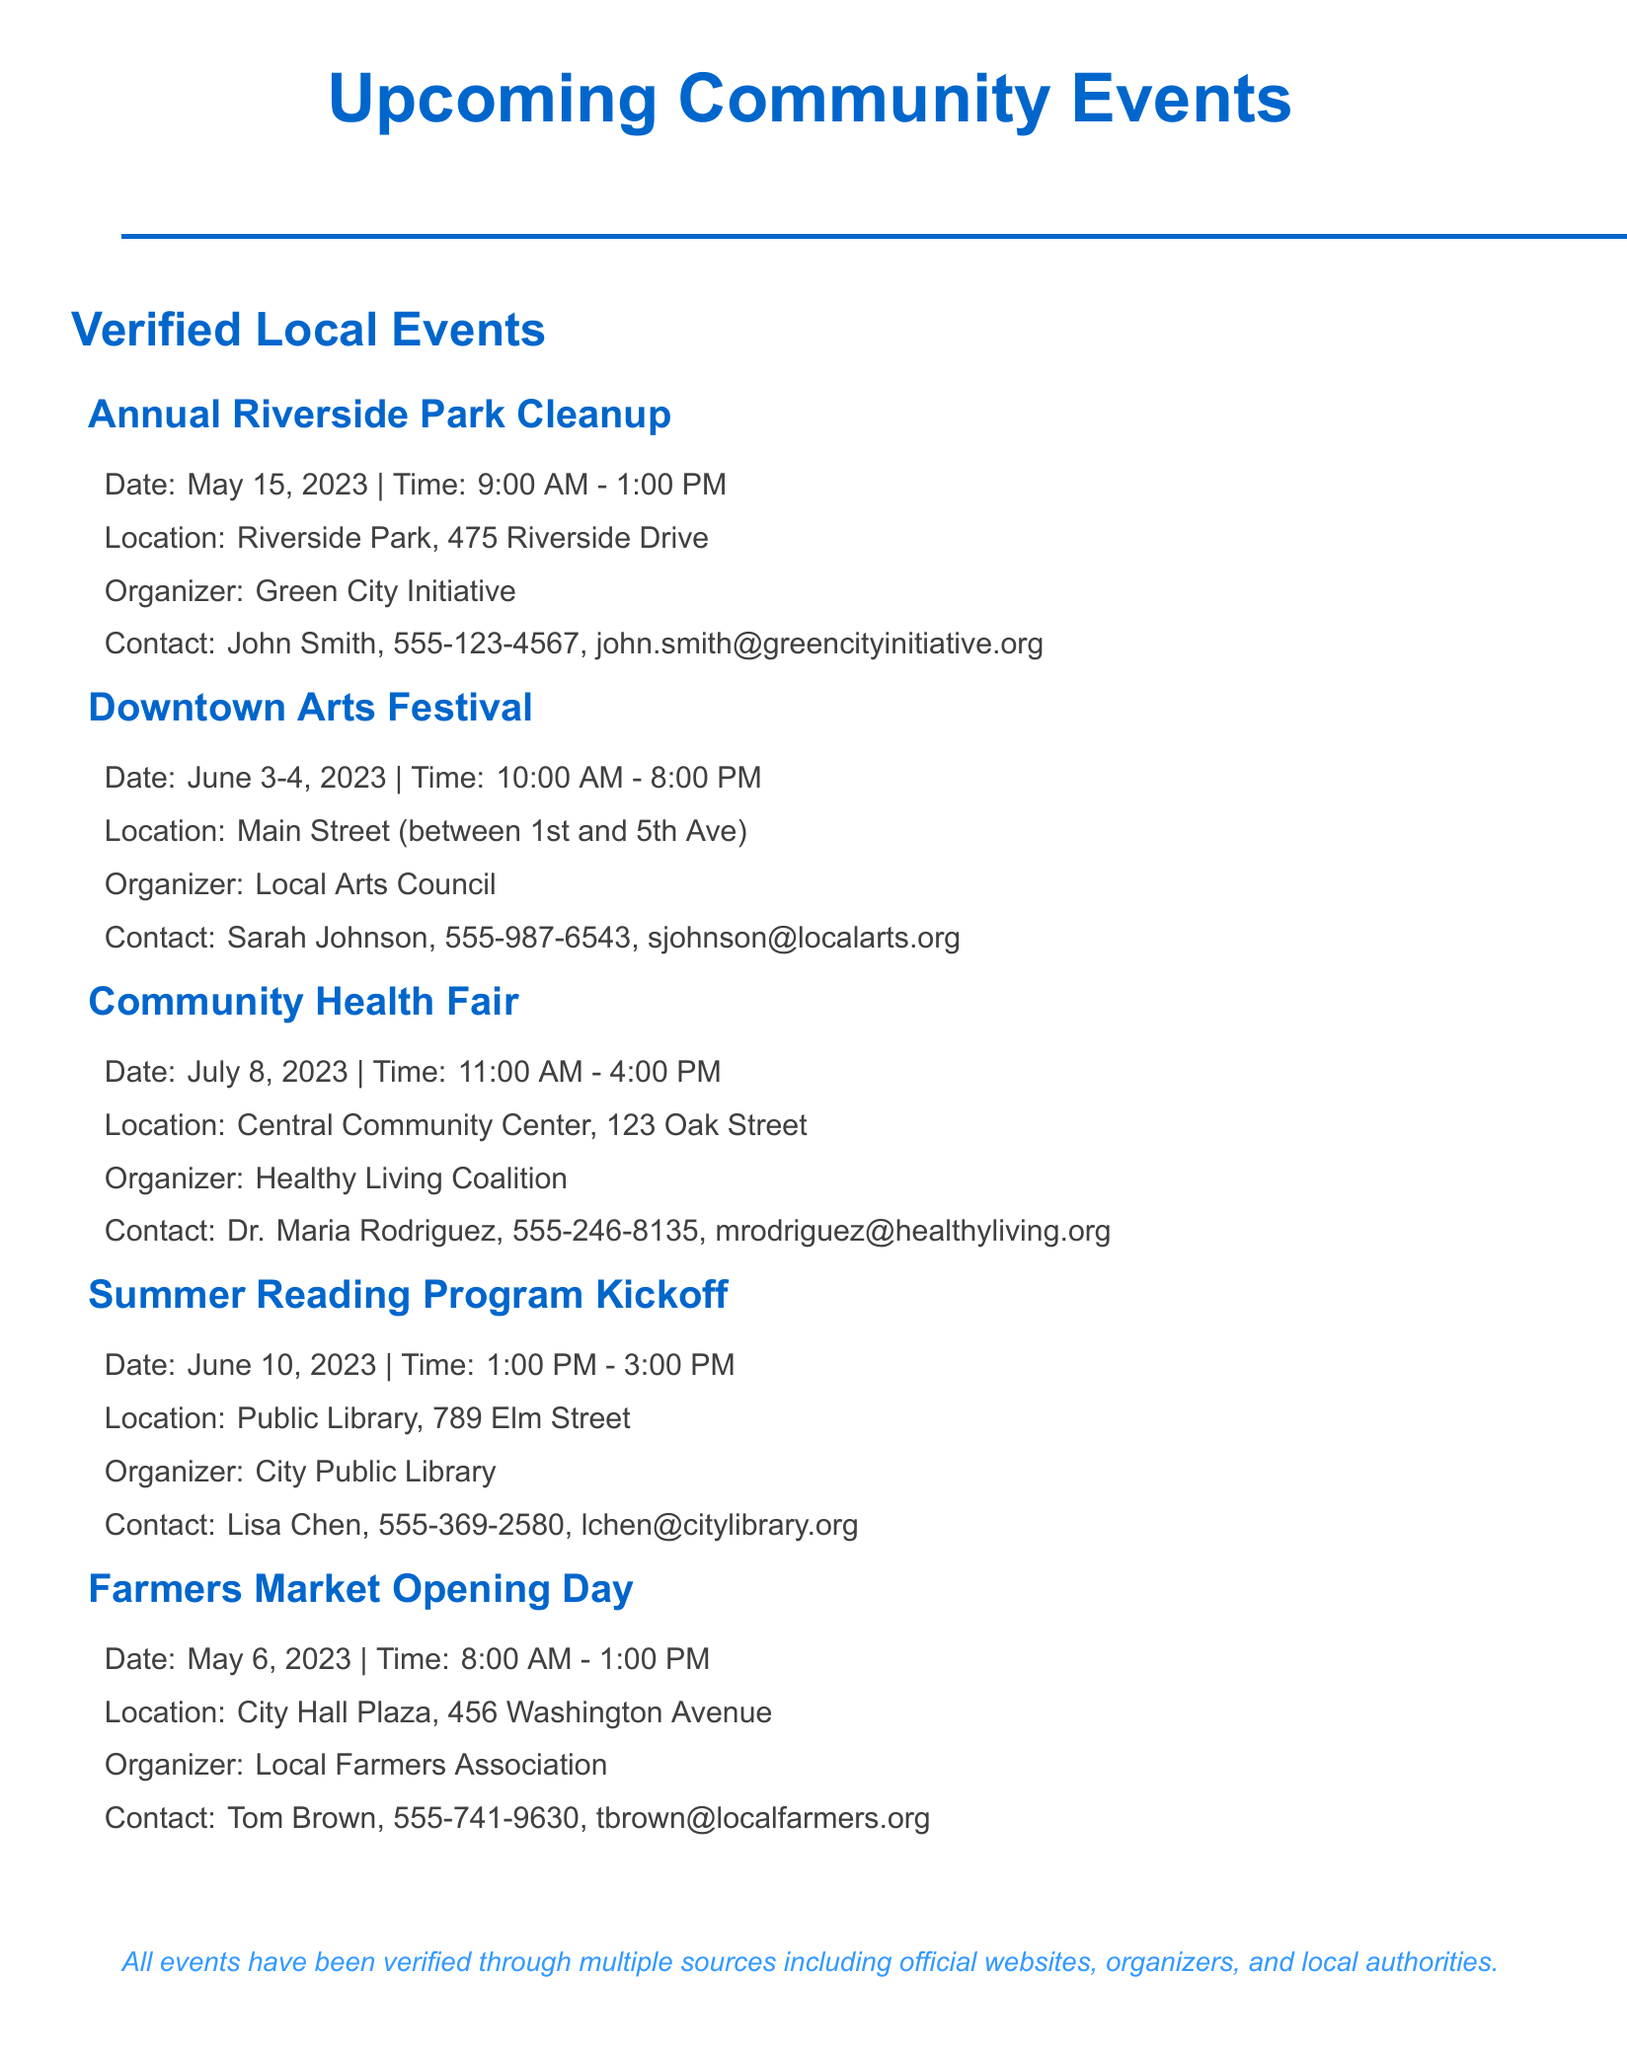What is the date of the Annual Riverside Park Cleanup? The date is specifically listed under the event details of that event.
Answer: May 15, 2023 Who is the contact person for the Downtown Arts Festival? The document lists the contact details for each event, including the organizer's contact person.
Answer: Sarah Johnson Where is the Community Health Fair held? The location of the event is clearly stated in its details.
Answer: Central Community Center, 123 Oak Street What time does the Summer Reading Program Kickoff start? The start time is mentioned in the event details under the specific event.
Answer: 1:00 PM How long does the Farmers Market Opening Day last? The duration is defined by the start and end times of the event in the document.
Answer: 5 hours Which organization is behind the Annual Riverside Park Cleanup? The organizer of the event is clearly specified in the document.
Answer: Green City Initiative What is the maximum time for the Downtown Arts Festival? The total duration is based on the provided event hours across the given dates.
Answer: 10 hours What type of event is scheduled on July 8, 2023? The specific event type is given in the event listing.
Answer: Community Health Fair Which event is confirmed with the Parks Department? This refers to the verification sources mentioned for events in the document.
Answer: Annual Riverside Park Cleanup 